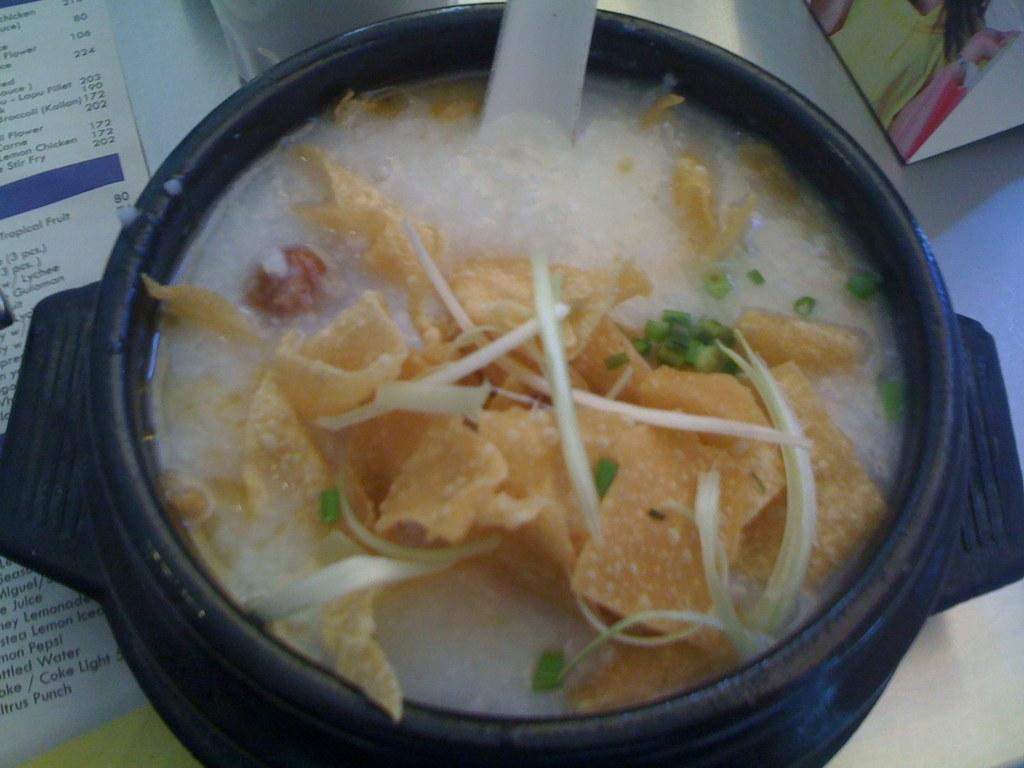Can you describe this image briefly? In this image, I can see a bowl with a food item. This looks like a paper. I can see a bowl, paper and few other objects on the table. 